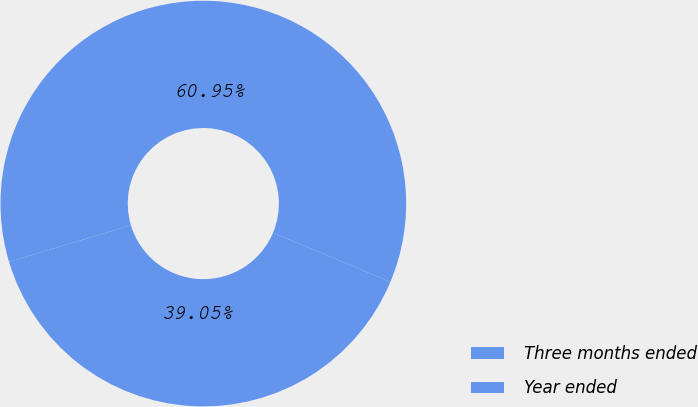Convert chart to OTSL. <chart><loc_0><loc_0><loc_500><loc_500><pie_chart><fcel>Three months ended<fcel>Year ended<nl><fcel>39.05%<fcel>60.95%<nl></chart> 